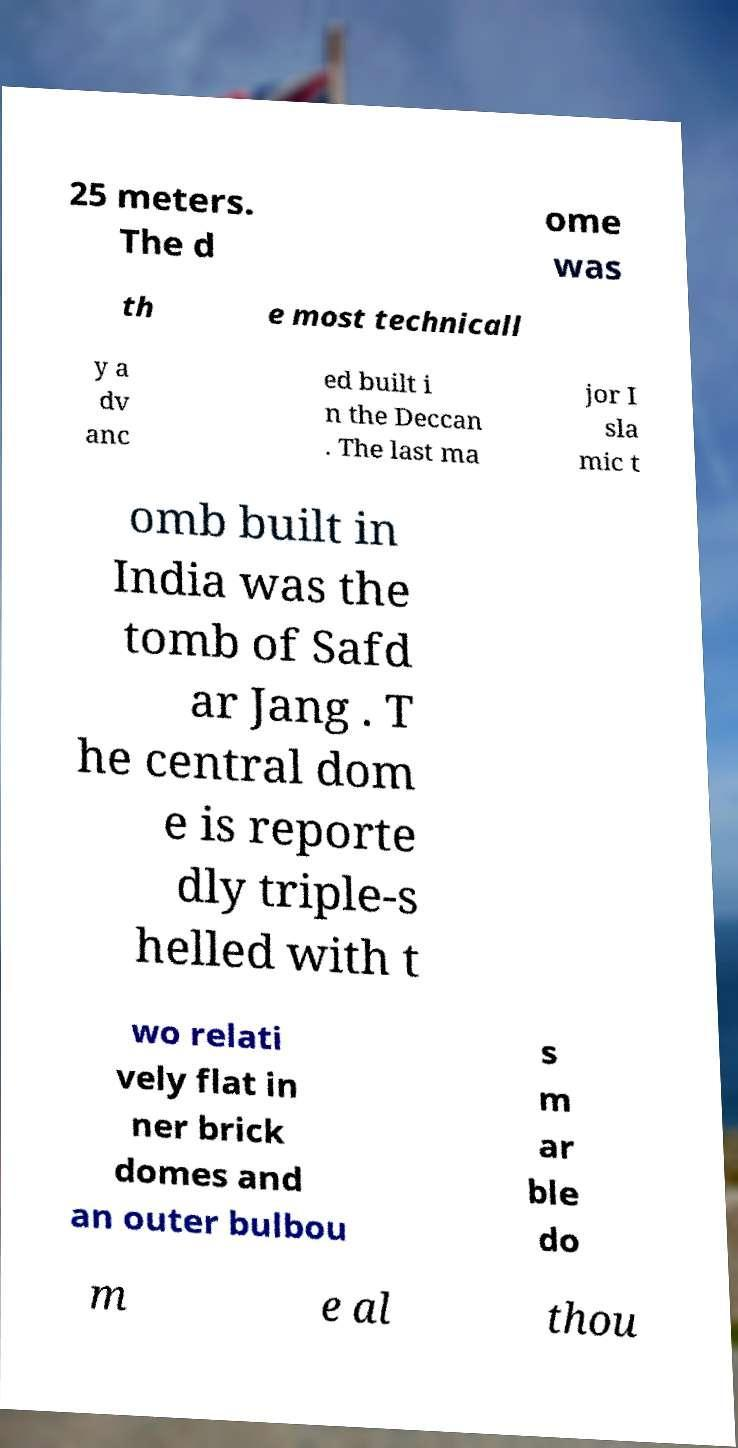Could you assist in decoding the text presented in this image and type it out clearly? 25 meters. The d ome was th e most technicall y a dv anc ed built i n the Deccan . The last ma jor I sla mic t omb built in India was the tomb of Safd ar Jang . T he central dom e is reporte dly triple-s helled with t wo relati vely flat in ner brick domes and an outer bulbou s m ar ble do m e al thou 